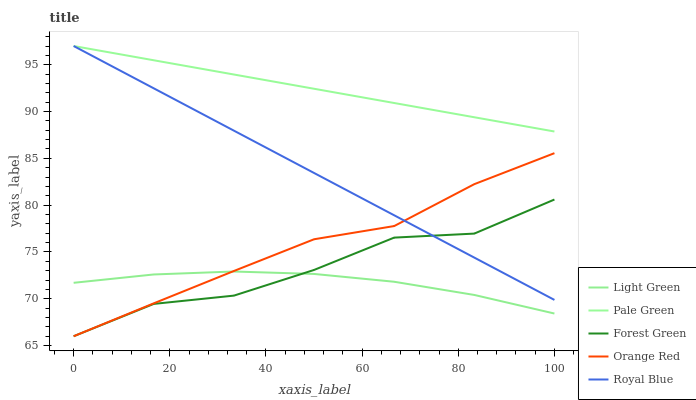Does Light Green have the minimum area under the curve?
Answer yes or no. Yes. Does Pale Green have the maximum area under the curve?
Answer yes or no. Yes. Does Forest Green have the minimum area under the curve?
Answer yes or no. No. Does Forest Green have the maximum area under the curve?
Answer yes or no. No. Is Royal Blue the smoothest?
Answer yes or no. Yes. Is Forest Green the roughest?
Answer yes or no. Yes. Is Pale Green the smoothest?
Answer yes or no. No. Is Pale Green the roughest?
Answer yes or no. No. Does Forest Green have the lowest value?
Answer yes or no. Yes. Does Pale Green have the lowest value?
Answer yes or no. No. Does Pale Green have the highest value?
Answer yes or no. Yes. Does Forest Green have the highest value?
Answer yes or no. No. Is Forest Green less than Pale Green?
Answer yes or no. Yes. Is Royal Blue greater than Light Green?
Answer yes or no. Yes. Does Light Green intersect Orange Red?
Answer yes or no. Yes. Is Light Green less than Orange Red?
Answer yes or no. No. Is Light Green greater than Orange Red?
Answer yes or no. No. Does Forest Green intersect Pale Green?
Answer yes or no. No. 